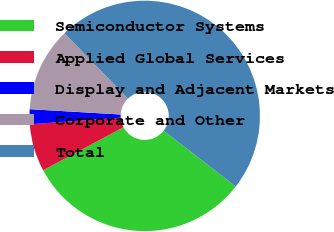Convert chart to OTSL. <chart><loc_0><loc_0><loc_500><loc_500><pie_chart><fcel>Semiconductor Systems<fcel>Applied Global Services<fcel>Display and Adjacent Markets<fcel>Corporate and Other<fcel>Total<nl><fcel>31.67%<fcel>6.66%<fcel>2.09%<fcel>11.81%<fcel>47.77%<nl></chart> 